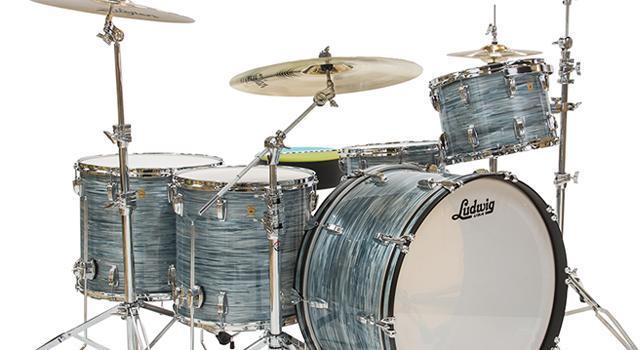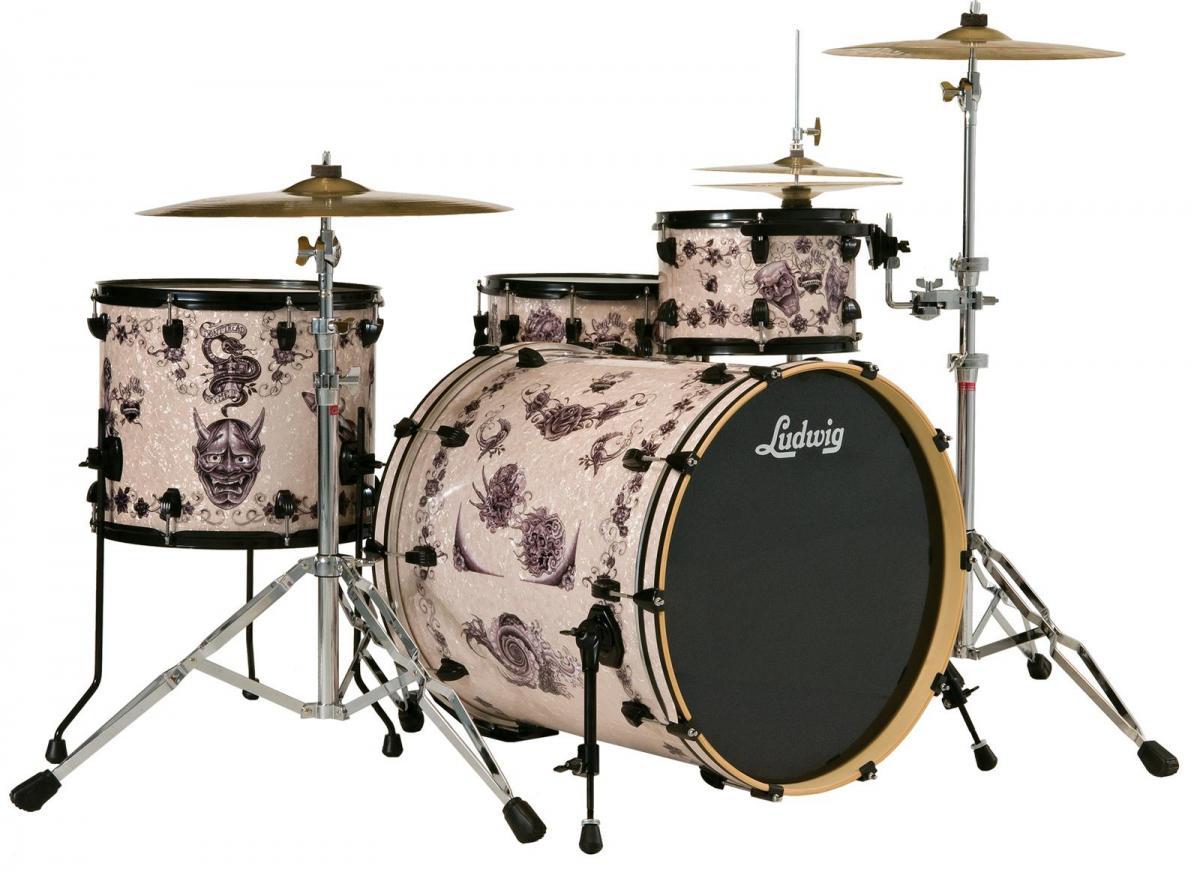The first image is the image on the left, the second image is the image on the right. Analyze the images presented: Is the assertion "Each image shows a drum kit, but only one image features a drum kit with at least one black-faced drum that is turned on its side." valid? Answer yes or no. Yes. 